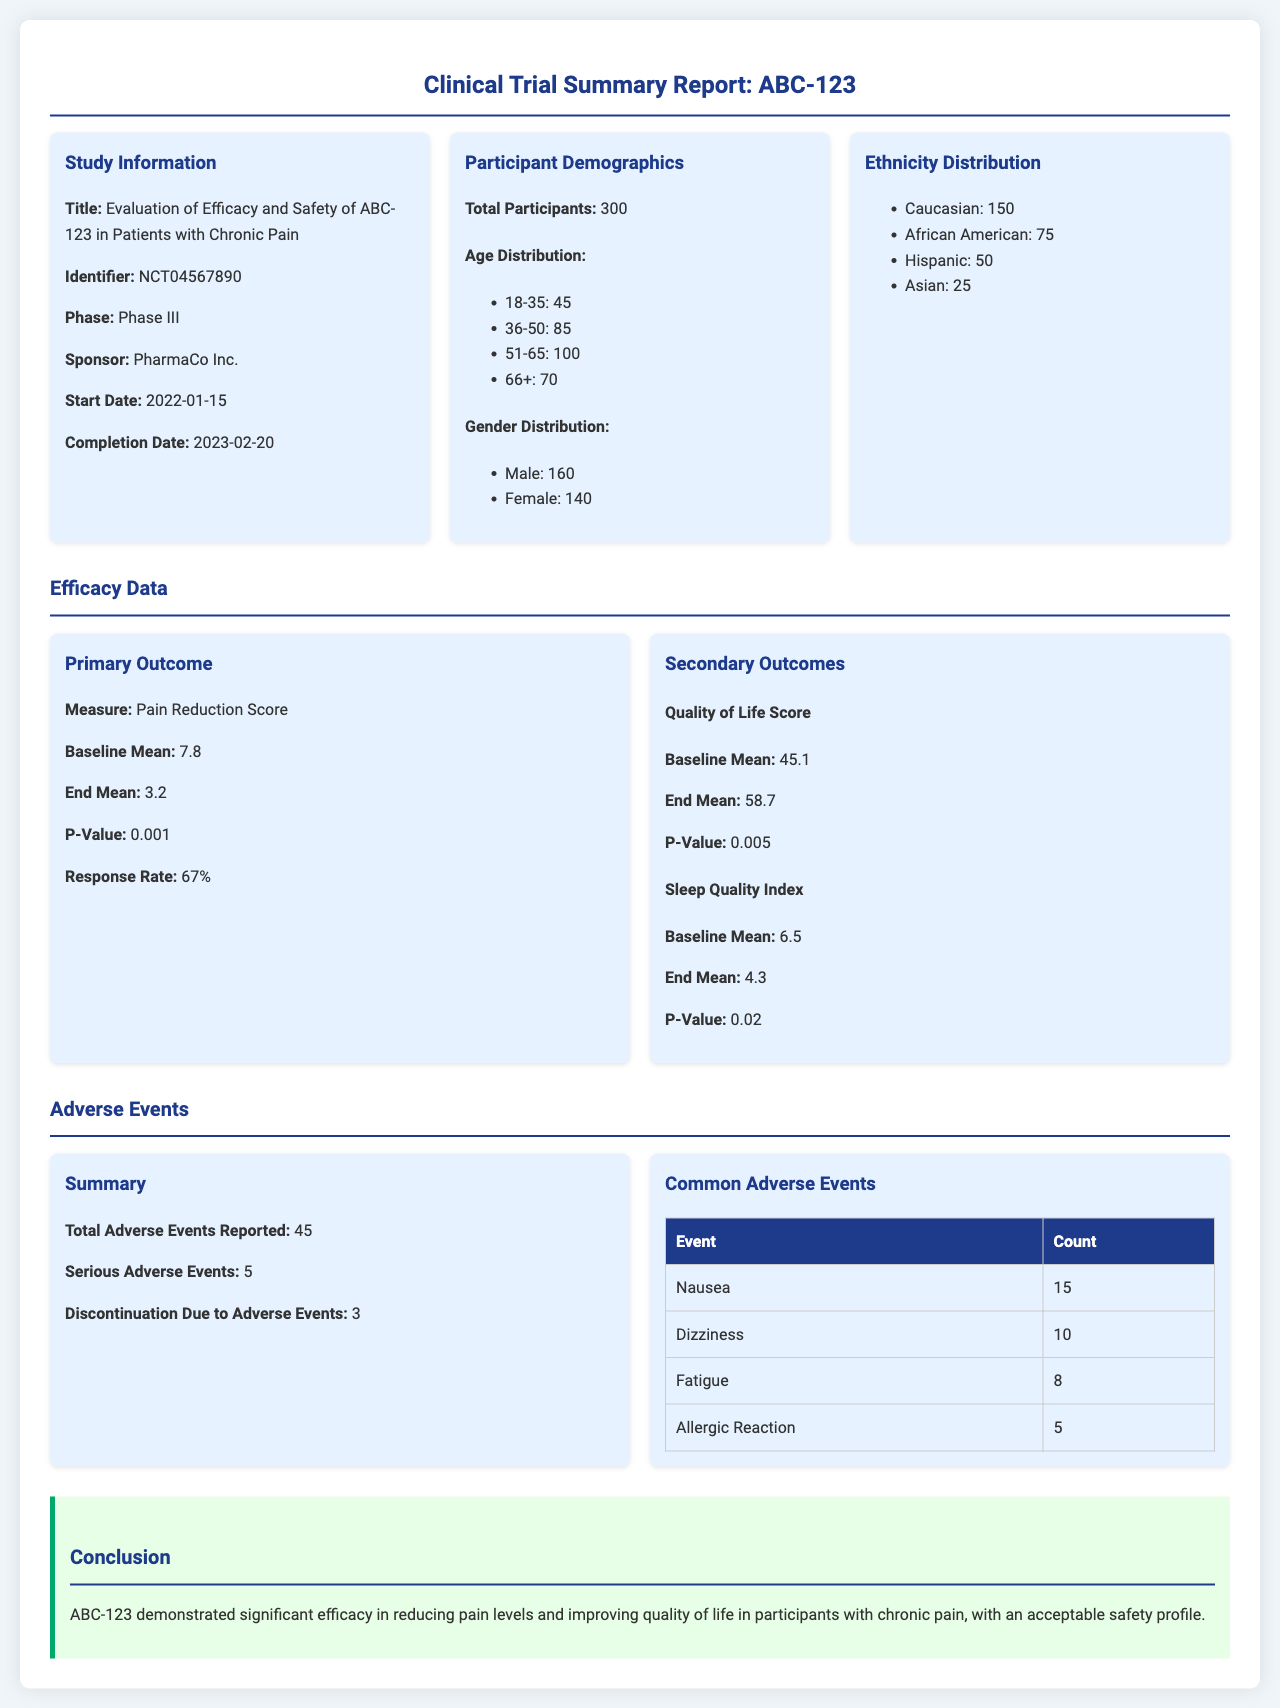What is the title of the study? The title of the study is presented in the section titled 'Study Information' in the report.
Answer: Evaluation of Efficacy and Safety of ABC-123 in Patients with Chronic Pain What is the identifier number for the study? The identifier number is found in the same section as the study title, referring to the clinical trial registry.
Answer: NCT04567890 How many total participants were involved in the study? The total number of participants is specified in the 'Participant Demographics' section of the report.
Answer: 300 What was the baseline mean for the Pain Reduction Score? The baseline mean for the Pain Reduction Score is shown in the 'Primary Outcome' subsection under 'Efficacy Data'.
Answer: 7.8 What was the response rate in the study? The response rate is mentioned in the 'Primary Outcome' subsection, relating to how effective the treatment was.
Answer: 67% How many serious adverse events were reported? The number of serious adverse events is indicated in the 'Adverse Events' section.
Answer: 5 What is the most common adverse event reported? The most common adverse event is identified in the 'Common Adverse Events' table, which lists the events by count.
Answer: Nausea What was the completion date of the study? The completion date is outlined in the 'Study Information' section.
Answer: 2023-02-20 What is the conclusion regarding the efficacy of ABC-123? The conclusion summarizes the overall findings related to the drug's effects as detailed in the 'Conclusion' section.
Answer: Demonstrated significant efficacy in reducing pain levels and improving quality of life 